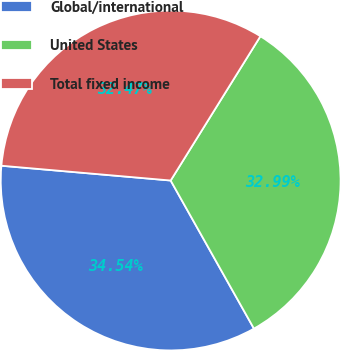Convert chart to OTSL. <chart><loc_0><loc_0><loc_500><loc_500><pie_chart><fcel>Global/international<fcel>United States<fcel>Total fixed income<nl><fcel>34.54%<fcel>32.99%<fcel>32.47%<nl></chart> 